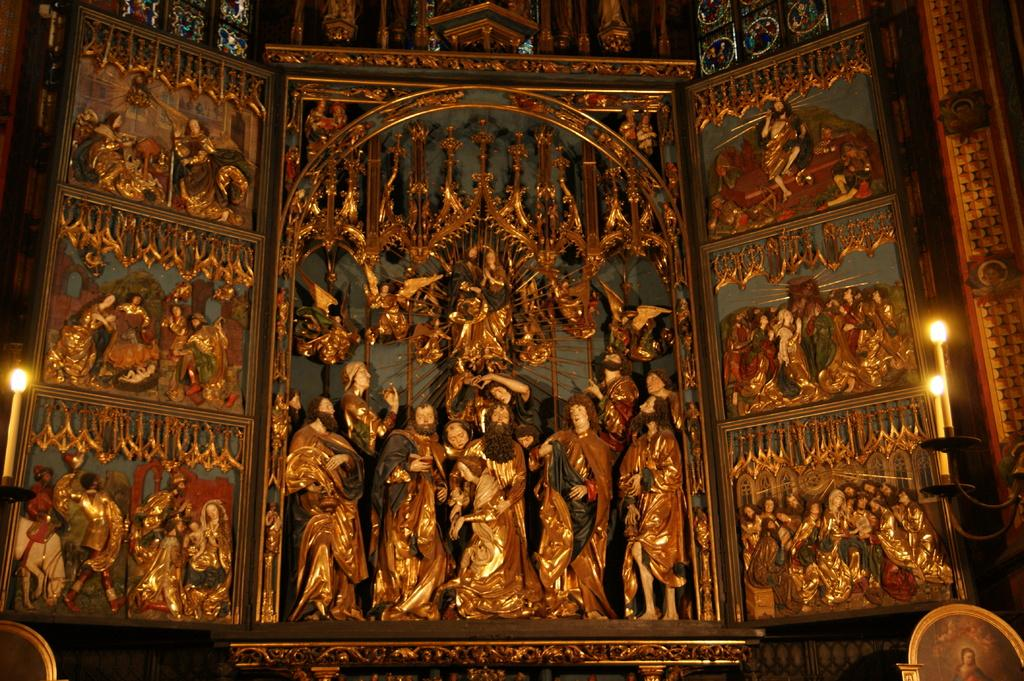What type of building is shown in the image? The image depicts the inner side of a church. What can be observed on the walls of the church? The walls of the church have carvings. What is included in the carvings on the walls? There are statues in the carvings. Can you describe the presence of lighting in the image? Candles are present on both sides of the image. What type of horn is being played by the statue in the image? There is no horn being played by a statue in the image; the statues are part of the carvings on the church walls. How many cherries are on the dress of the statue in the image? There is no dress or cherries present on any of the statues in the image. 